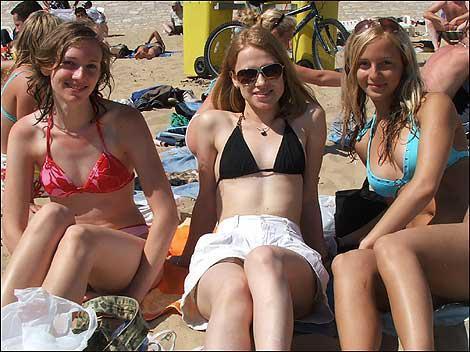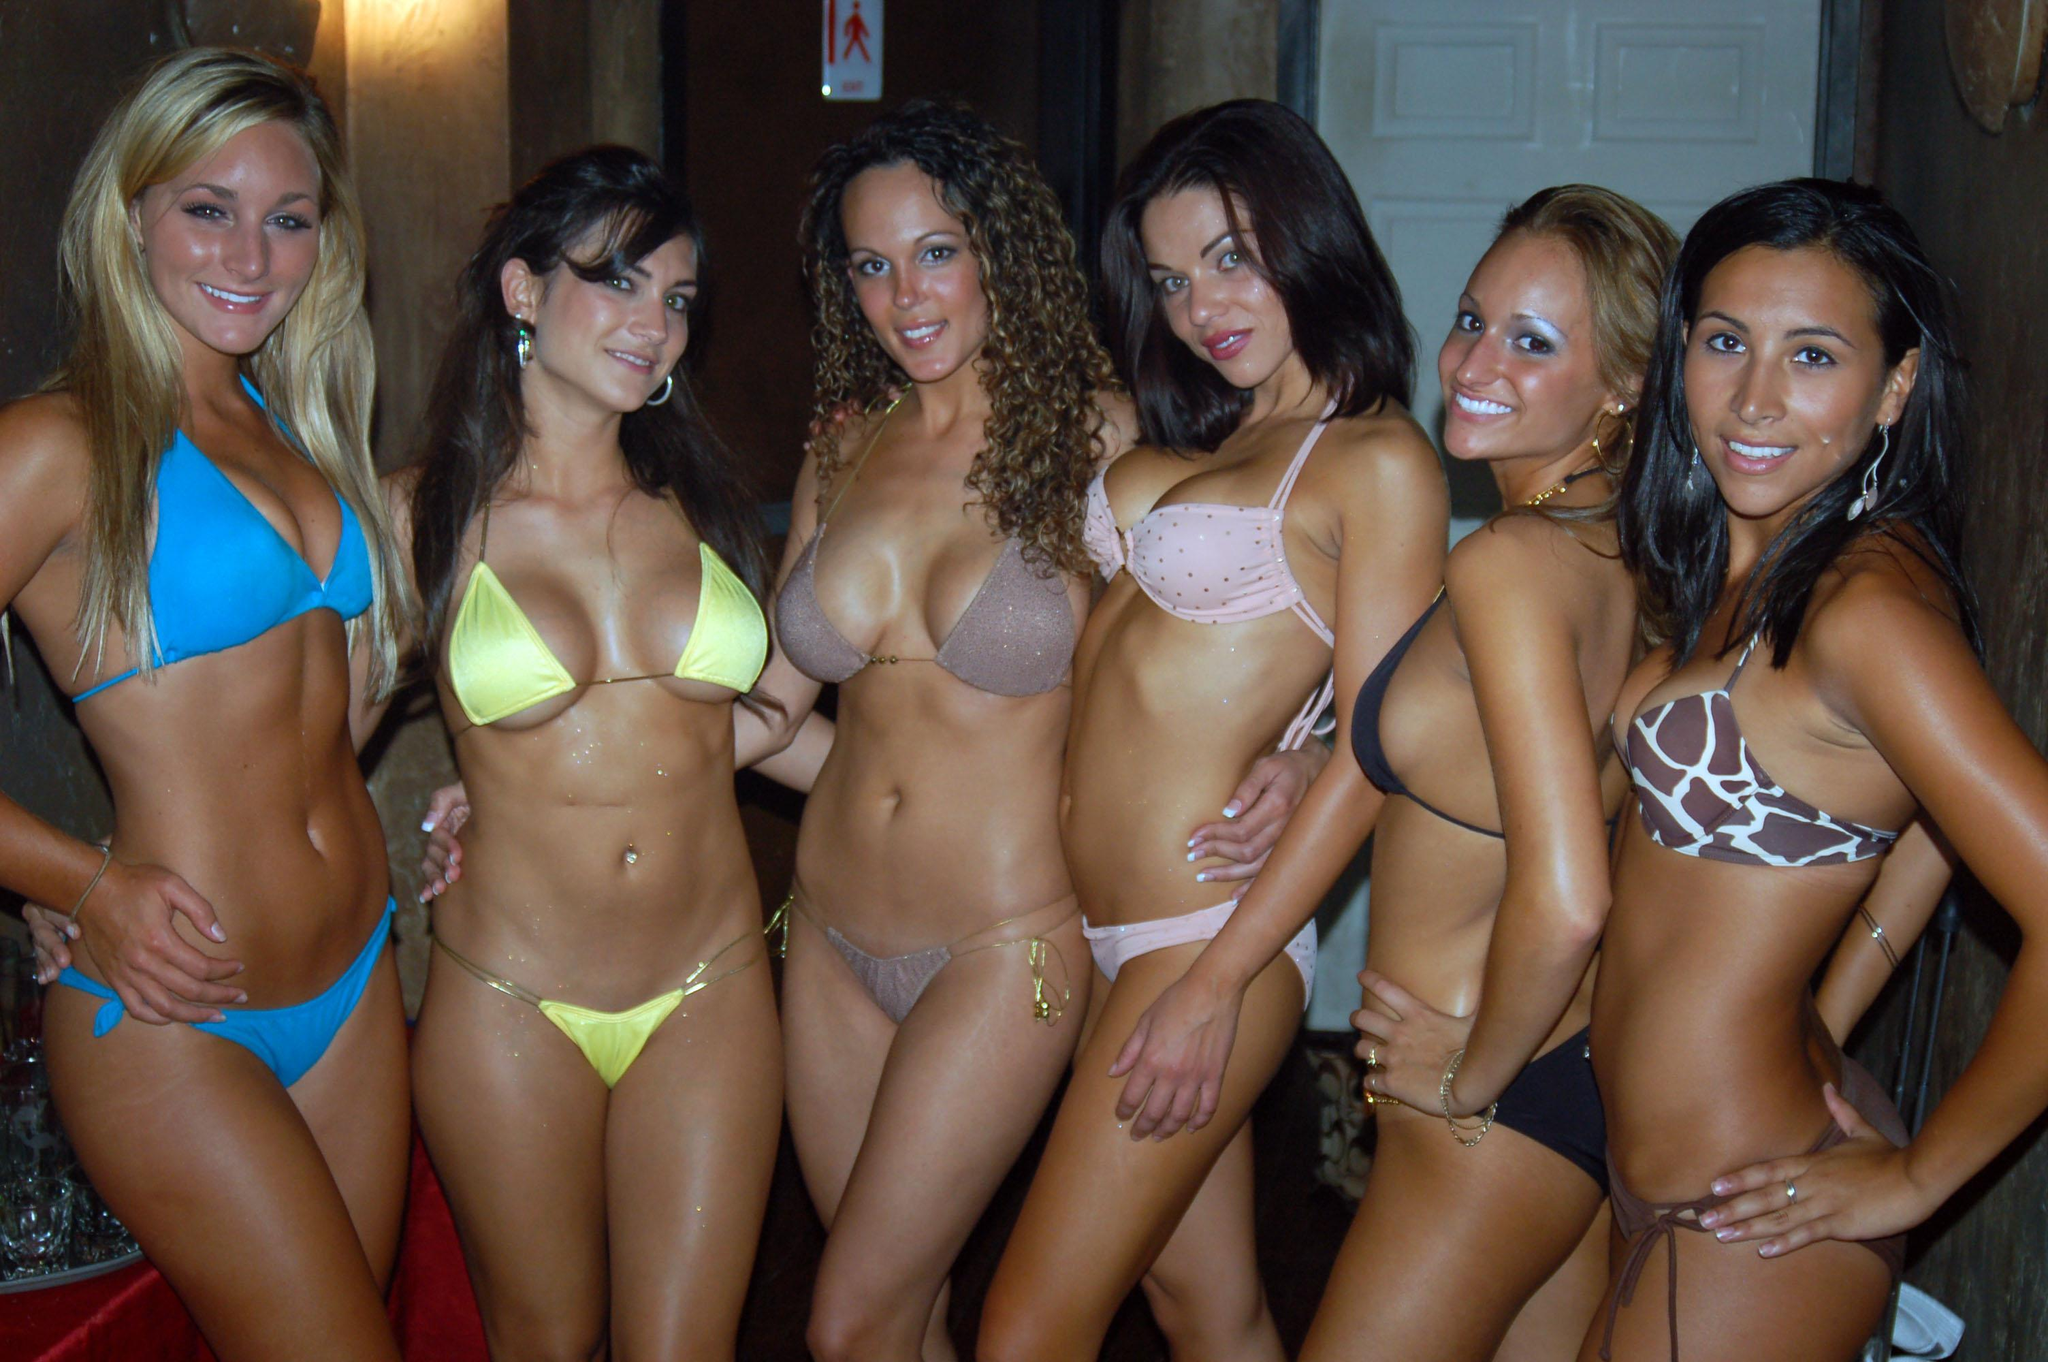The first image is the image on the left, the second image is the image on the right. Given the left and right images, does the statement "There are exactly three girls standing in one of the images." hold true? Answer yes or no. No. 